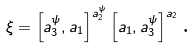Convert formula to latex. <formula><loc_0><loc_0><loc_500><loc_500>\xi = \left [ a _ { 3 } ^ { \psi } , a _ { 1 } \right ] ^ { a _ { 2 } ^ { \psi } } \left [ a _ { 1 } , a _ { 3 } ^ { \psi } \right ] ^ { a _ { 2 } } \text {.}</formula> 